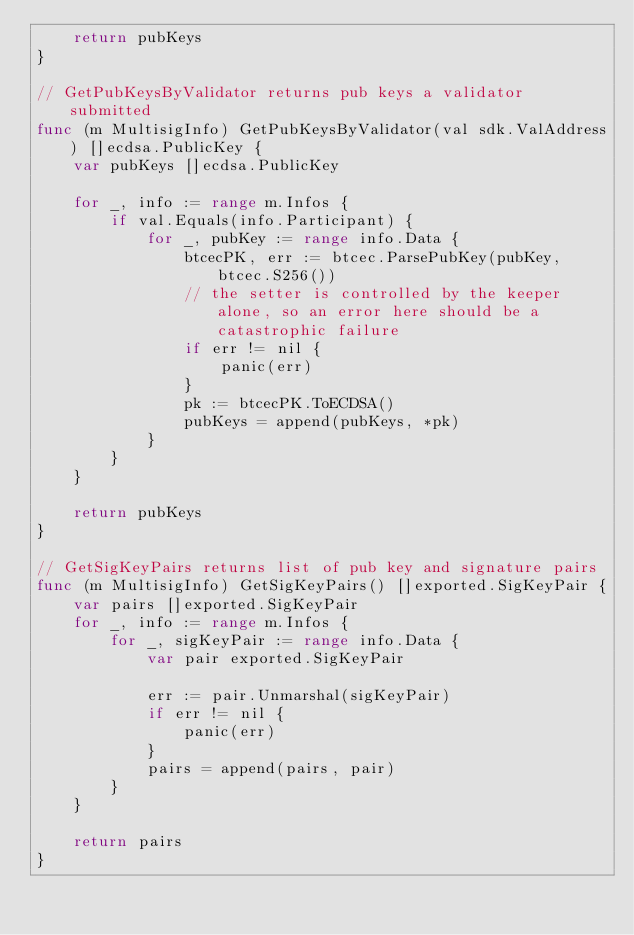Convert code to text. <code><loc_0><loc_0><loc_500><loc_500><_Go_>	return pubKeys
}

// GetPubKeysByValidator returns pub keys a validator submitted
func (m MultisigInfo) GetPubKeysByValidator(val sdk.ValAddress) []ecdsa.PublicKey {
	var pubKeys []ecdsa.PublicKey

	for _, info := range m.Infos {
		if val.Equals(info.Participant) {
			for _, pubKey := range info.Data {
				btcecPK, err := btcec.ParsePubKey(pubKey, btcec.S256())
				// the setter is controlled by the keeper alone, so an error here should be a catastrophic failure
				if err != nil {
					panic(err)
				}
				pk := btcecPK.ToECDSA()
				pubKeys = append(pubKeys, *pk)
			}
		}
	}

	return pubKeys
}

// GetSigKeyPairs returns list of pub key and signature pairs
func (m MultisigInfo) GetSigKeyPairs() []exported.SigKeyPair {
	var pairs []exported.SigKeyPair
	for _, info := range m.Infos {
		for _, sigKeyPair := range info.Data {
			var pair exported.SigKeyPair

			err := pair.Unmarshal(sigKeyPair)
			if err != nil {
				panic(err)
			}
			pairs = append(pairs, pair)
		}
	}

	return pairs
}
</code> 